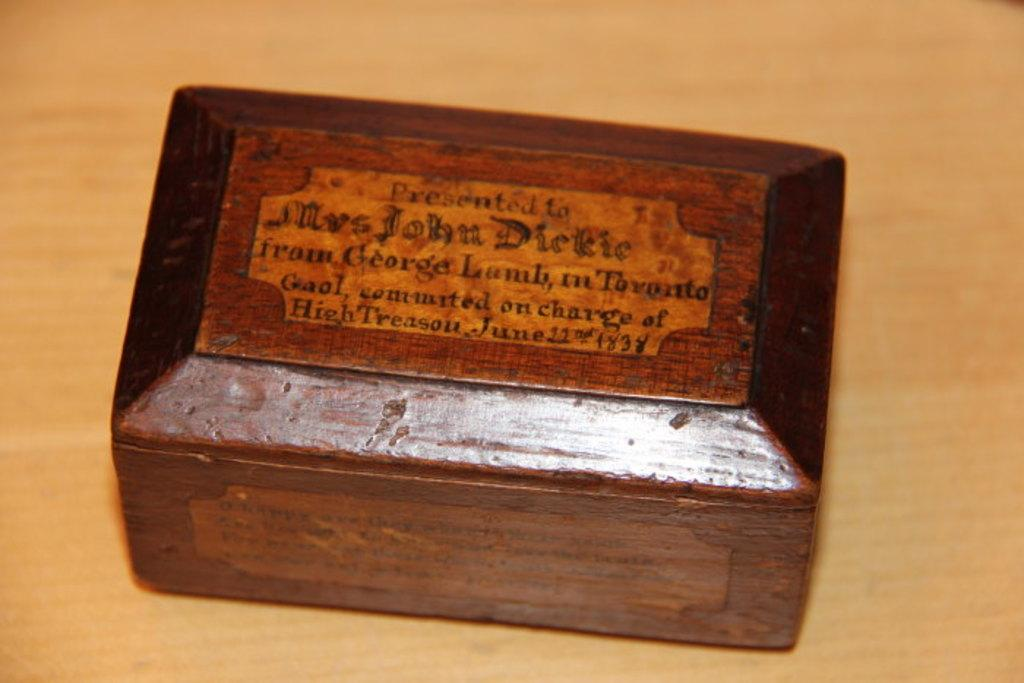<image>
Offer a succinct explanation of the picture presented. A wooden box is dated June 11, 1838. 